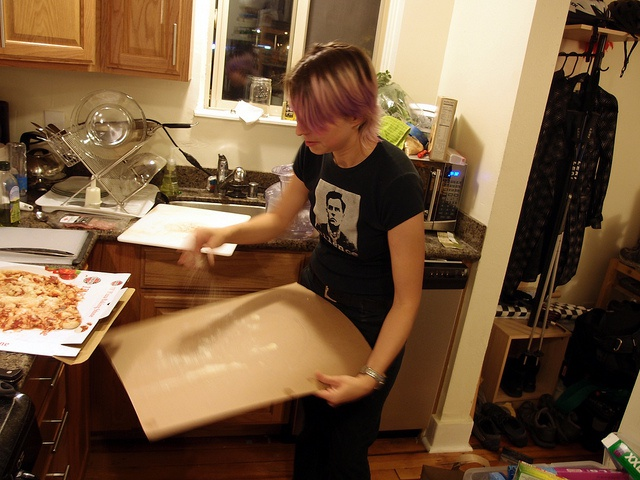Describe the objects in this image and their specific colors. I can see people in gray, black, brown, and maroon tones, pizza in gray, orange, tan, ivory, and red tones, oven in gray, black, and maroon tones, microwave in gray, black, maroon, and brown tones, and sink in gray, olive, tan, and ivory tones in this image. 